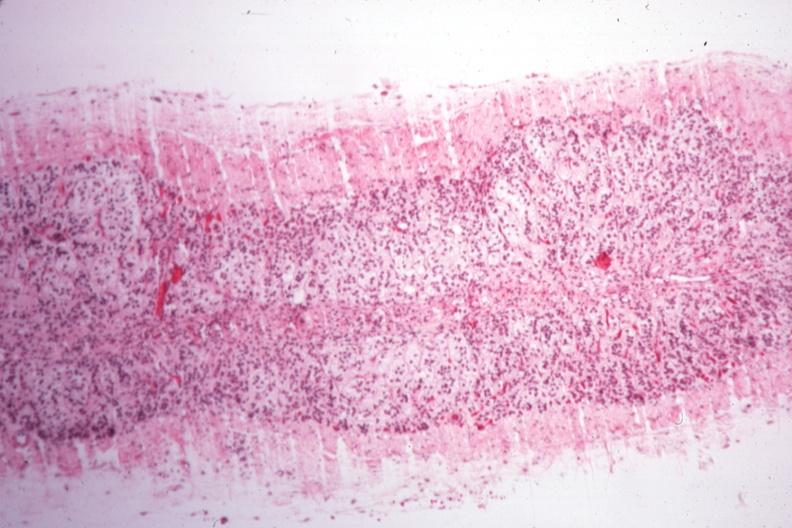s adrenal present?
Answer the question using a single word or phrase. Yes 